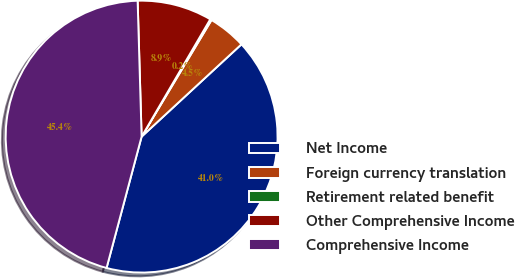Convert chart. <chart><loc_0><loc_0><loc_500><loc_500><pie_chart><fcel>Net Income<fcel>Foreign currency translation<fcel>Retirement related benefit<fcel>Other Comprehensive Income<fcel>Comprehensive Income<nl><fcel>41.02%<fcel>4.53%<fcel>0.17%<fcel>8.89%<fcel>45.38%<nl></chart> 